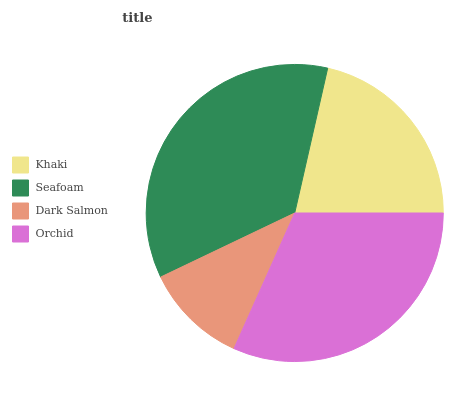Is Dark Salmon the minimum?
Answer yes or no. Yes. Is Seafoam the maximum?
Answer yes or no. Yes. Is Seafoam the minimum?
Answer yes or no. No. Is Dark Salmon the maximum?
Answer yes or no. No. Is Seafoam greater than Dark Salmon?
Answer yes or no. Yes. Is Dark Salmon less than Seafoam?
Answer yes or no. Yes. Is Dark Salmon greater than Seafoam?
Answer yes or no. No. Is Seafoam less than Dark Salmon?
Answer yes or no. No. Is Orchid the high median?
Answer yes or no. Yes. Is Khaki the low median?
Answer yes or no. Yes. Is Dark Salmon the high median?
Answer yes or no. No. Is Seafoam the low median?
Answer yes or no. No. 